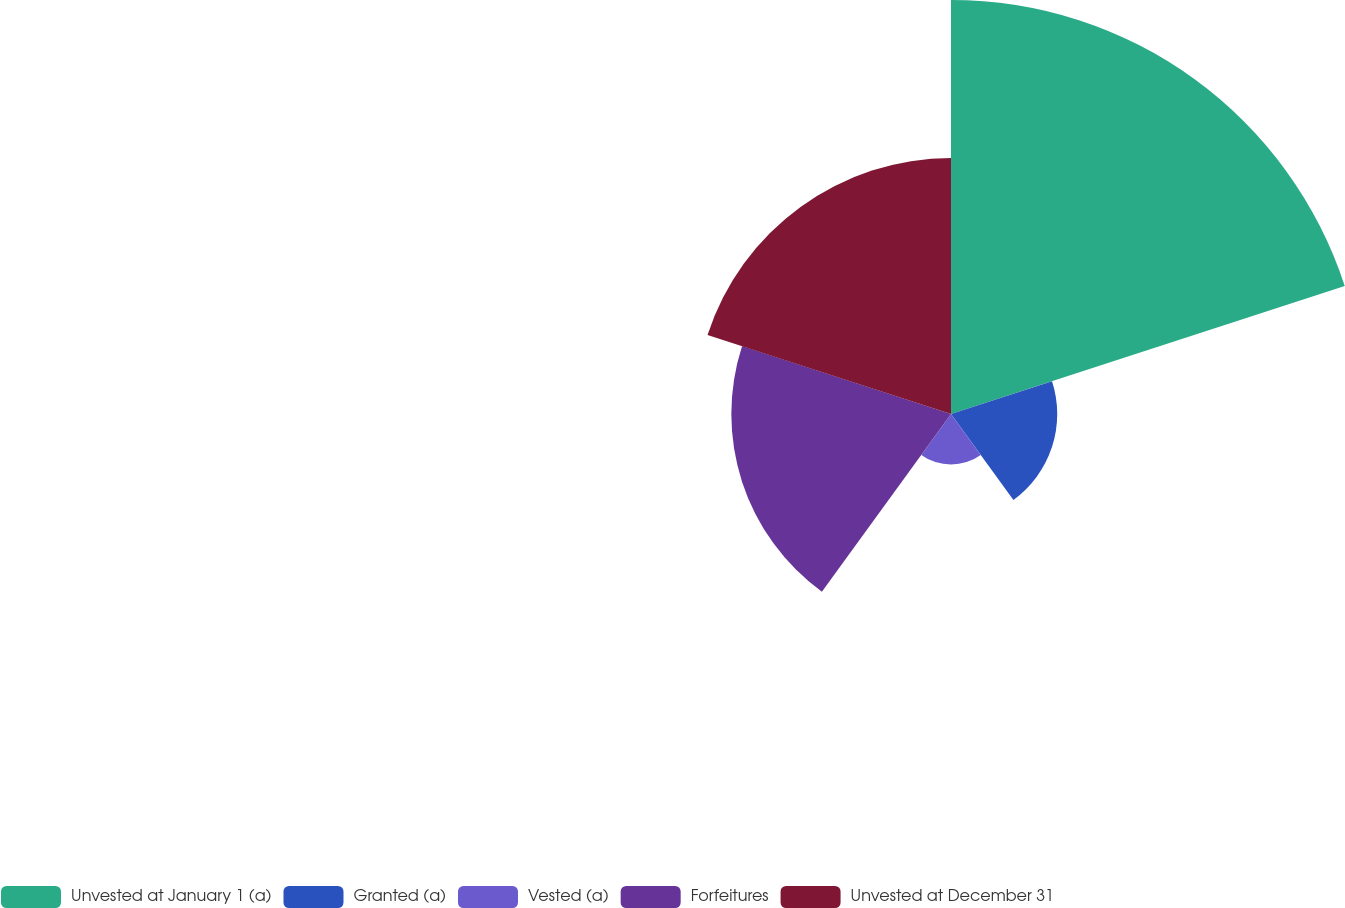Convert chart. <chart><loc_0><loc_0><loc_500><loc_500><pie_chart><fcel>Unvested at January 1 (a)<fcel>Granted (a)<fcel>Vested (a)<fcel>Forfeitures<fcel>Unvested at December 31<nl><fcel>39.56%<fcel>10.15%<fcel>4.83%<fcel>20.99%<fcel>24.46%<nl></chart> 